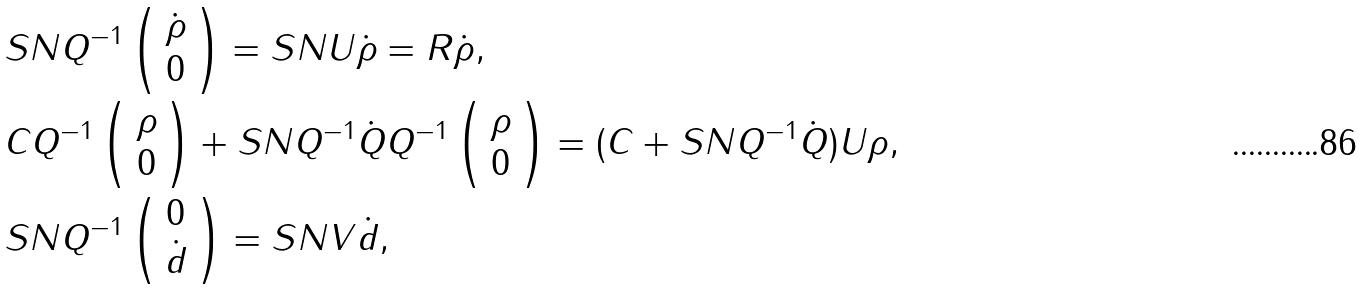<formula> <loc_0><loc_0><loc_500><loc_500>& S N Q ^ { - 1 } \left ( \begin{array} { c } \dot { \rho } \\ 0 \end{array} \right ) = S N U \dot { \rho } = R \dot { \rho } , \\ & C Q ^ { - 1 } \left ( \begin{array} { c } \rho \\ 0 \end{array} \right ) + S N Q ^ { - 1 } \dot { Q } Q ^ { - 1 } \left ( \begin{array} { c } \rho \\ 0 \end{array} \right ) = ( C + S N Q ^ { - 1 } \dot { Q } ) U \rho , \\ & S N Q ^ { - 1 } \left ( \begin{array} { c } 0 \\ \dot { d } \end{array} \right ) = S N V \dot { d } ,</formula> 